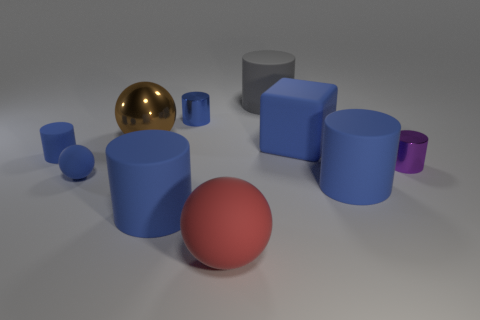Are there any green metallic cubes?
Offer a terse response. No. The metallic object that is on the left side of the tiny metal object that is left of the big gray rubber cylinder is what shape?
Ensure brevity in your answer.  Sphere. How many objects are either small blue cylinders or cylinders in front of the large gray thing?
Make the answer very short. 5. The tiny cylinder on the right side of the big ball right of the tiny metal cylinder that is to the left of the purple shiny thing is what color?
Provide a short and direct response. Purple. There is a purple object that is the same shape as the gray object; what is it made of?
Your response must be concise. Metal. The large metallic ball is what color?
Keep it short and to the point. Brown. Does the small matte ball have the same color as the tiny matte cylinder?
Your answer should be very brief. Yes. What number of rubber objects are brown balls or blue blocks?
Give a very brief answer. 1. Is there a large metallic object in front of the tiny cylinder that is right of the blue rubber cylinder that is right of the blue shiny cylinder?
Keep it short and to the point. No. What is the size of the blue block that is made of the same material as the big red sphere?
Your response must be concise. Large. 